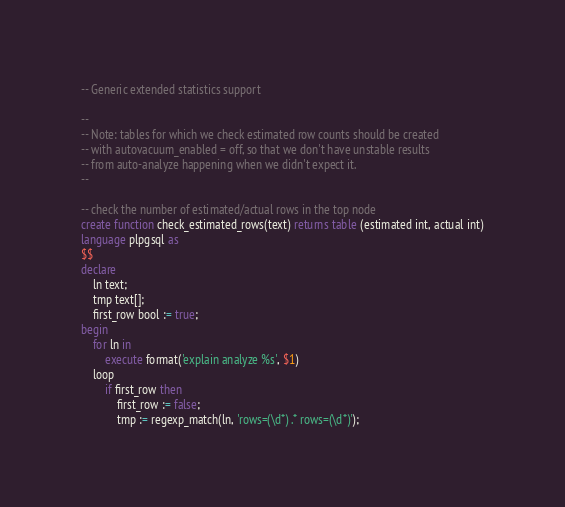Convert code to text. <code><loc_0><loc_0><loc_500><loc_500><_SQL_>-- Generic extended statistics support

--
-- Note: tables for which we check estimated row counts should be created
-- with autovacuum_enabled = off, so that we don't have unstable results
-- from auto-analyze happening when we didn't expect it.
--

-- check the number of estimated/actual rows in the top node
create function check_estimated_rows(text) returns table (estimated int, actual int)
language plpgsql as
$$
declare
    ln text;
    tmp text[];
    first_row bool := true;
begin
    for ln in
        execute format('explain analyze %s', $1)
    loop
        if first_row then
            first_row := false;
            tmp := regexp_match(ln, 'rows=(\d*) .* rows=(\d*)');</code> 